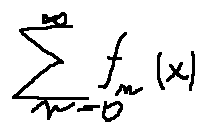<formula> <loc_0><loc_0><loc_500><loc_500>\sum \lim i t s _ { n = 0 } ^ { \infty } f _ { n } ( x )</formula> 